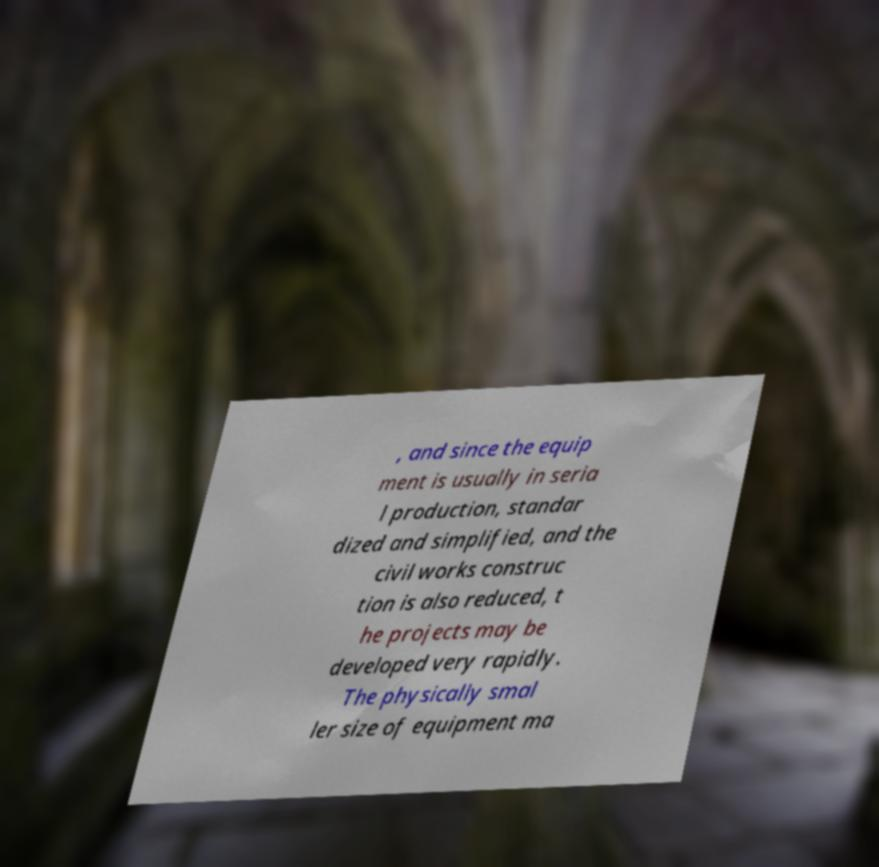Can you read and provide the text displayed in the image?This photo seems to have some interesting text. Can you extract and type it out for me? , and since the equip ment is usually in seria l production, standar dized and simplified, and the civil works construc tion is also reduced, t he projects may be developed very rapidly. The physically smal ler size of equipment ma 